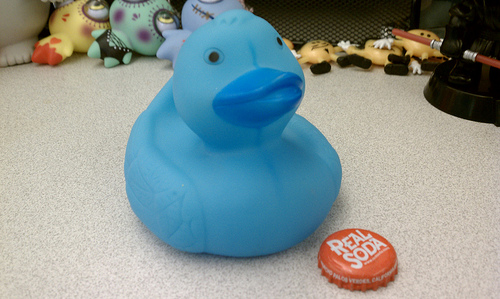<image>
Can you confirm if the ducky is next to the soda cap? Yes. The ducky is positioned adjacent to the soda cap, located nearby in the same general area. 